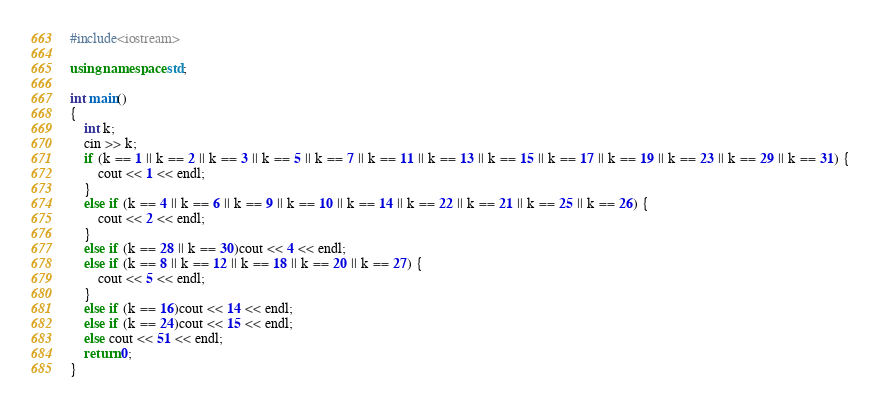Convert code to text. <code><loc_0><loc_0><loc_500><loc_500><_C++_>#include<iostream>

using namespace std;

int main()
{
	int k;
	cin >> k;
	if (k == 1 || k == 2 || k == 3 || k == 5 || k == 7 || k == 11 || k == 13 || k == 15 || k == 17 || k == 19 || k == 23 || k == 29 || k == 31) {
		cout << 1 << endl;
	}
	else if (k == 4 || k == 6 || k == 9 || k == 10 || k == 14 || k == 22 || k == 21 || k == 25 || k == 26) {
		cout << 2 << endl;
	}
	else if (k == 28 || k == 30)cout << 4 << endl;
	else if (k == 8 || k == 12 || k == 18 || k == 20 || k == 27) {
		cout << 5 << endl;
	}
	else if (k == 16)cout << 14 << endl;
	else if (k == 24)cout << 15 << endl;
	else cout << 51 << endl;
    return 0;
}
</code> 